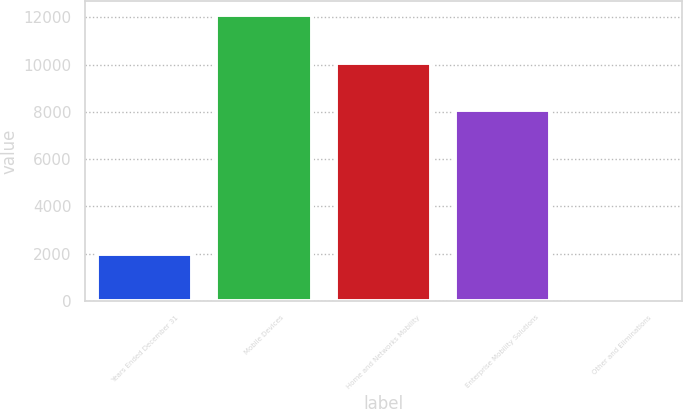Convert chart. <chart><loc_0><loc_0><loc_500><loc_500><bar_chart><fcel>Years Ended December 31<fcel>Mobile Devices<fcel>Home and Networks Mobility<fcel>Enterprise Mobility Solutions<fcel>Other and Eliminations<nl><fcel>2008<fcel>12099<fcel>10086<fcel>8093<fcel>132<nl></chart> 